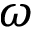<formula> <loc_0><loc_0><loc_500><loc_500>\omega</formula> 